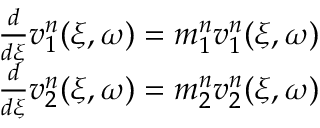Convert formula to latex. <formula><loc_0><loc_0><loc_500><loc_500>\begin{array} { r } { \frac { d } { d \xi } v _ { 1 } ^ { n } ( \xi , \omega ) = m _ { 1 } ^ { n } v _ { 1 } ^ { n } ( \xi , \omega ) } \\ { \frac { d } { d \xi } v _ { 2 } ^ { n } ( \xi , \omega ) = m _ { 2 } ^ { n } v _ { 2 } ^ { n } ( \xi , \omega ) } \end{array}</formula> 